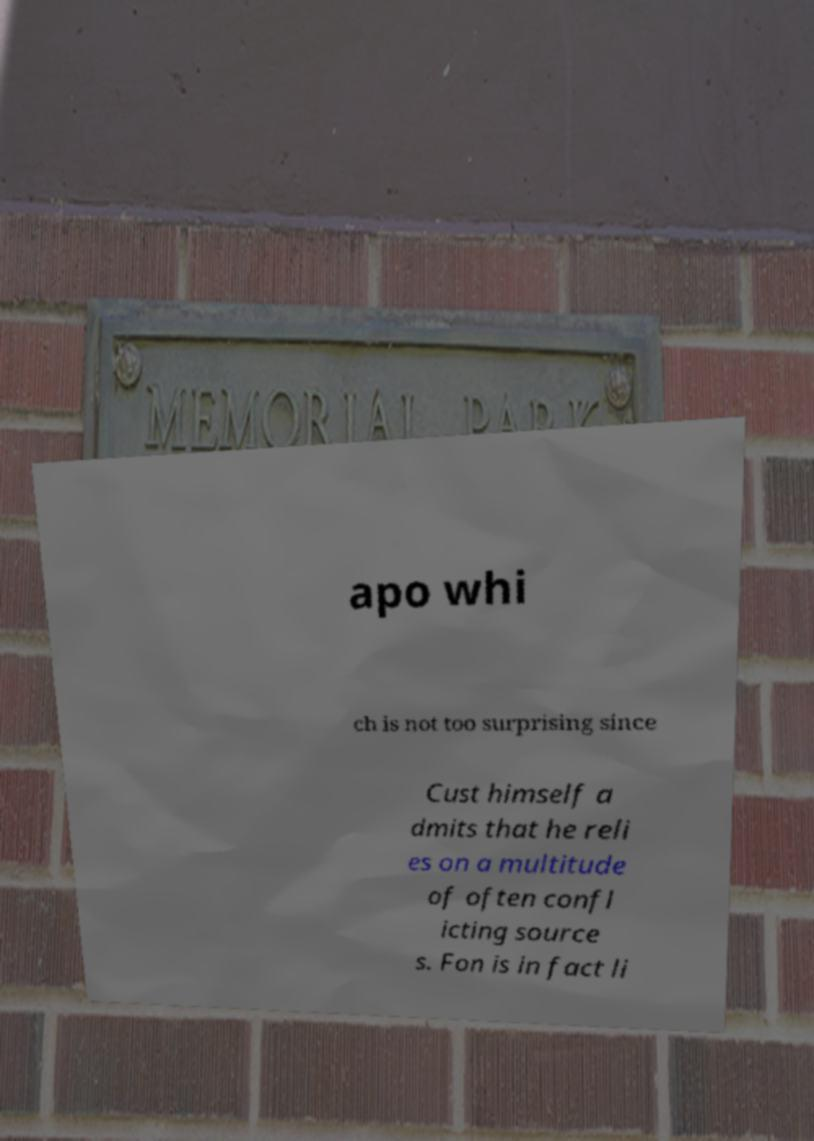Can you read and provide the text displayed in the image?This photo seems to have some interesting text. Can you extract and type it out for me? apo whi ch is not too surprising since Cust himself a dmits that he reli es on a multitude of often confl icting source s. Fon is in fact li 